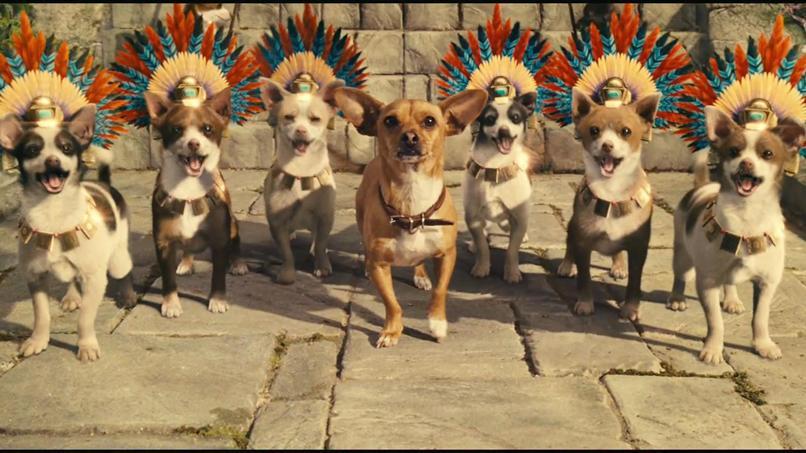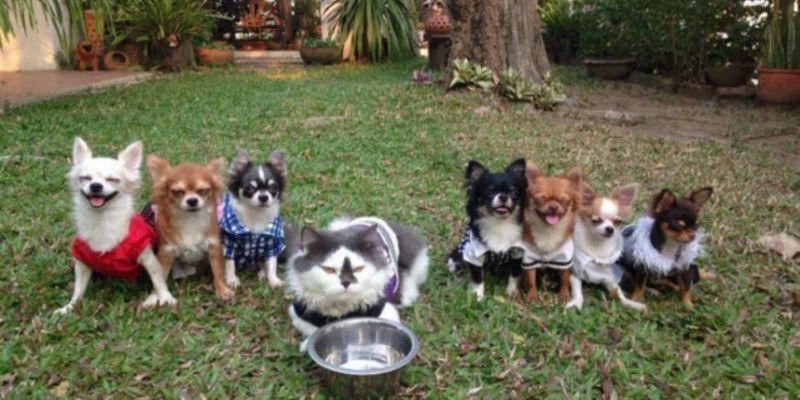The first image is the image on the left, the second image is the image on the right. For the images displayed, is the sentence "In one image, chihuahuas are arranged in a horizontal line with a gray cat toward the middle of the row." factually correct? Answer yes or no. Yes. The first image is the image on the left, the second image is the image on the right. Evaluate the accuracy of this statement regarding the images: "At least one dog is wearing a red shirt.". Is it true? Answer yes or no. Yes. 